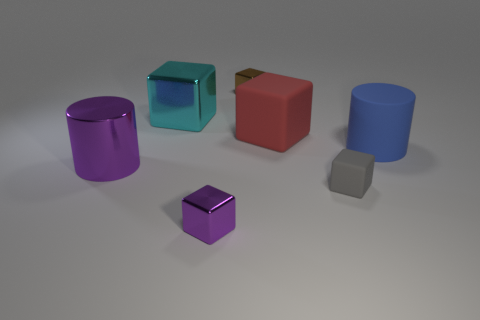There is a thing that is the same color as the shiny cylinder; what shape is it?
Provide a short and direct response. Cube. Does the big object in front of the blue cylinder have the same color as the small metal block that is in front of the metallic cylinder?
Your answer should be compact. Yes. The metal block that is the same color as the large metallic cylinder is what size?
Ensure brevity in your answer.  Small. Is the color of the big object in front of the blue matte cylinder the same as the big matte cube?
Ensure brevity in your answer.  No. There is another metallic thing that is the same shape as the blue thing; what size is it?
Your answer should be very brief. Large. What material is the small block that is left of the brown cube right of the metal cube in front of the big blue cylinder made of?
Ensure brevity in your answer.  Metal. Is the number of big blue matte things to the left of the big purple metal cylinder greater than the number of big blue cylinders left of the tiny gray matte thing?
Your answer should be very brief. No. Do the purple metallic cylinder and the purple cube have the same size?
Ensure brevity in your answer.  No. There is another big object that is the same shape as the red matte thing; what is its color?
Ensure brevity in your answer.  Cyan. How many big rubber cylinders are the same color as the tiny rubber block?
Your response must be concise. 0. 